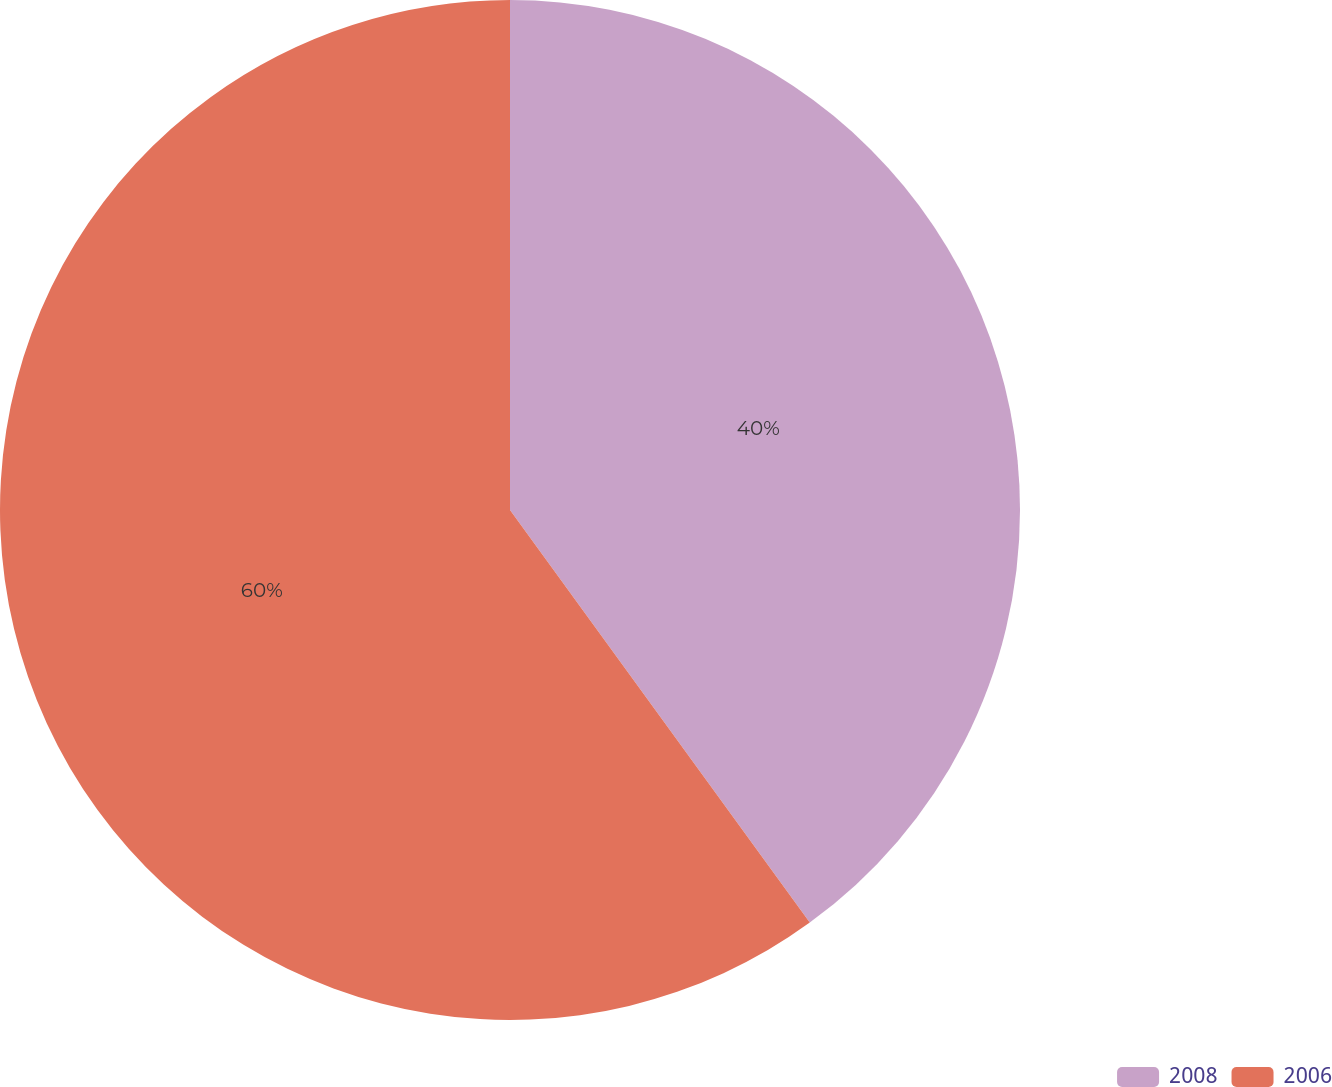Convert chart. <chart><loc_0><loc_0><loc_500><loc_500><pie_chart><fcel>2008<fcel>2006<nl><fcel>40.0%<fcel>60.0%<nl></chart> 